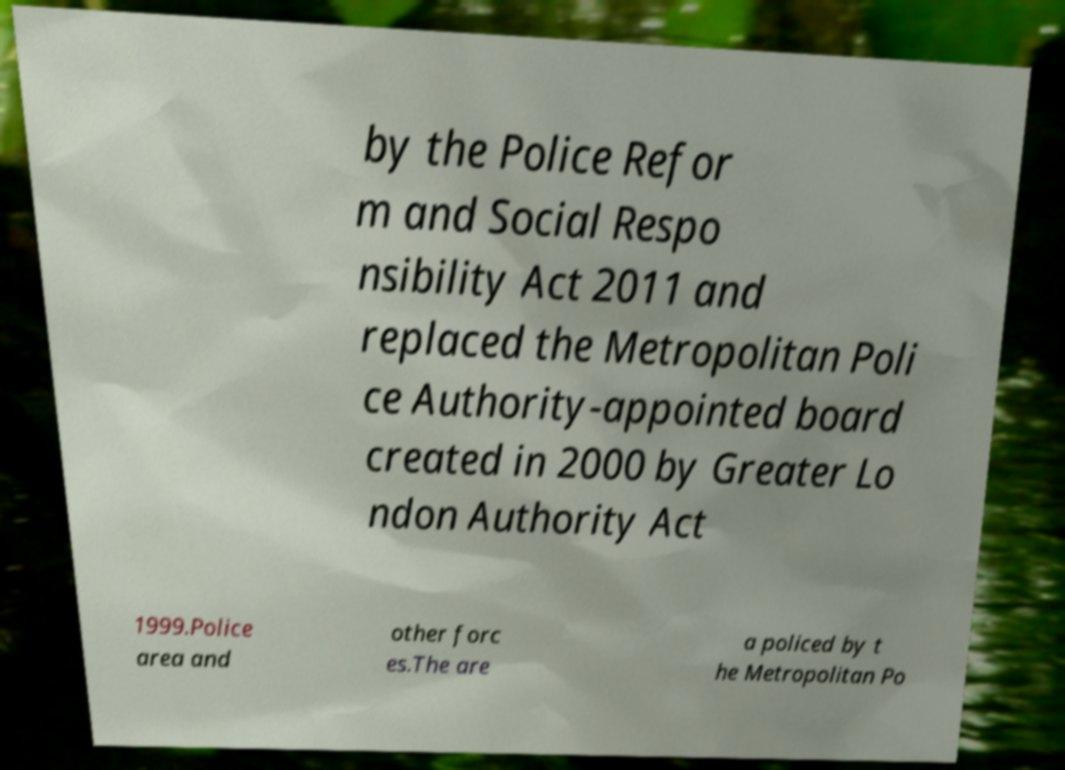There's text embedded in this image that I need extracted. Can you transcribe it verbatim? by the Police Refor m and Social Respo nsibility Act 2011 and replaced the Metropolitan Poli ce Authority-appointed board created in 2000 by Greater Lo ndon Authority Act 1999.Police area and other forc es.The are a policed by t he Metropolitan Po 